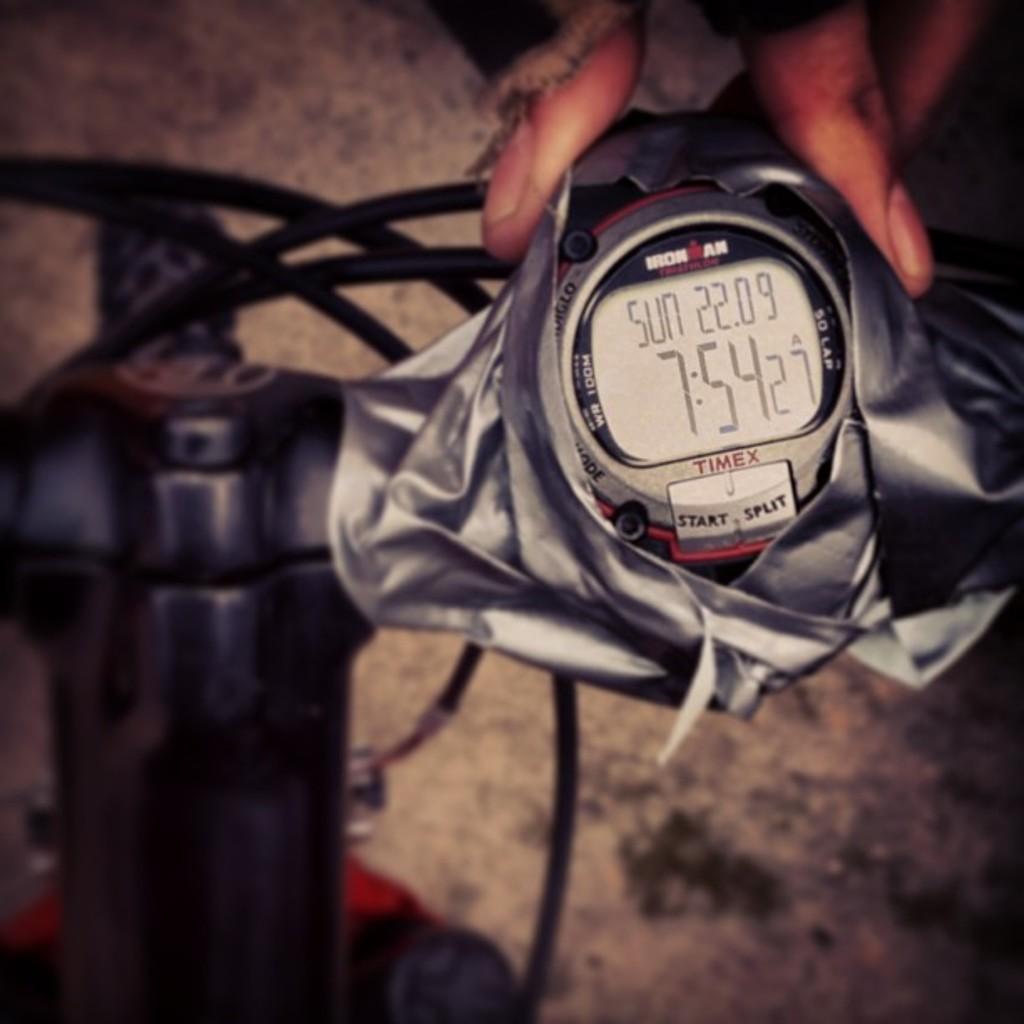What brand watch is this?
Your answer should be very brief. Timex. What day of the week is it?
Give a very brief answer. Sunday. 